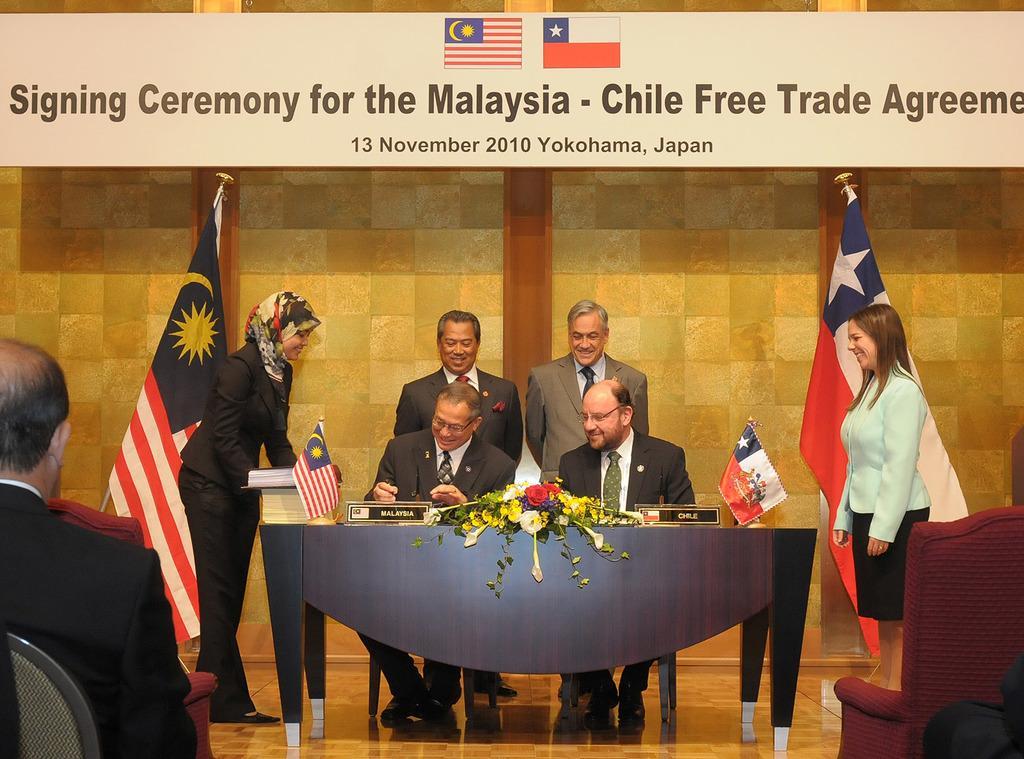Describe this image in one or two sentences. In this picture we can see four persons are standing and two are persons sitting in front of a table, there is a man sitting on a chair at the left bottom, in the background there are two flags, a wall and a board, we can see some text on the board. 